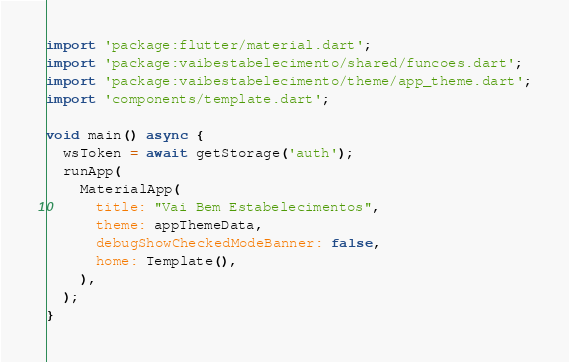<code> <loc_0><loc_0><loc_500><loc_500><_Dart_>import 'package:flutter/material.dart';
import 'package:vaibestabelecimento/shared/funcoes.dart';
import 'package:vaibestabelecimento/theme/app_theme.dart';
import 'components/template.dart';

void main() async {
  wsToken = await getStorage('auth');
  runApp(
    MaterialApp(
      title: "Vai Bem Estabelecimentos",
      theme: appThemeData,
      debugShowCheckedModeBanner: false,
      home: Template(),
    ),
  );
}
</code> 